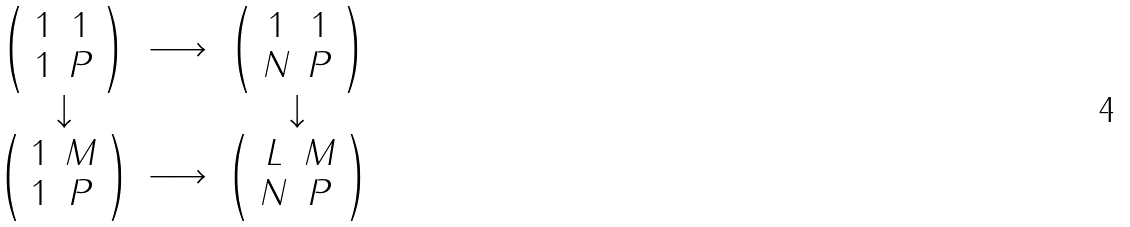<formula> <loc_0><loc_0><loc_500><loc_500>\begin{array} { c c c } { \left ( \begin{array} { c c } 1 & 1 \\ 1 & P \end{array} \right ) } & \longrightarrow & { \left ( \begin{array} { c c } 1 & 1 \\ N & P \end{array} \right ) } \\ \downarrow & & \downarrow \\ { \left ( \begin{array} { c c } 1 & M \\ 1 & P \end{array} \right ) } & \longrightarrow & { \left ( \begin{array} { c c } L & M \\ N & P \end{array} \right ) } \end{array}</formula> 